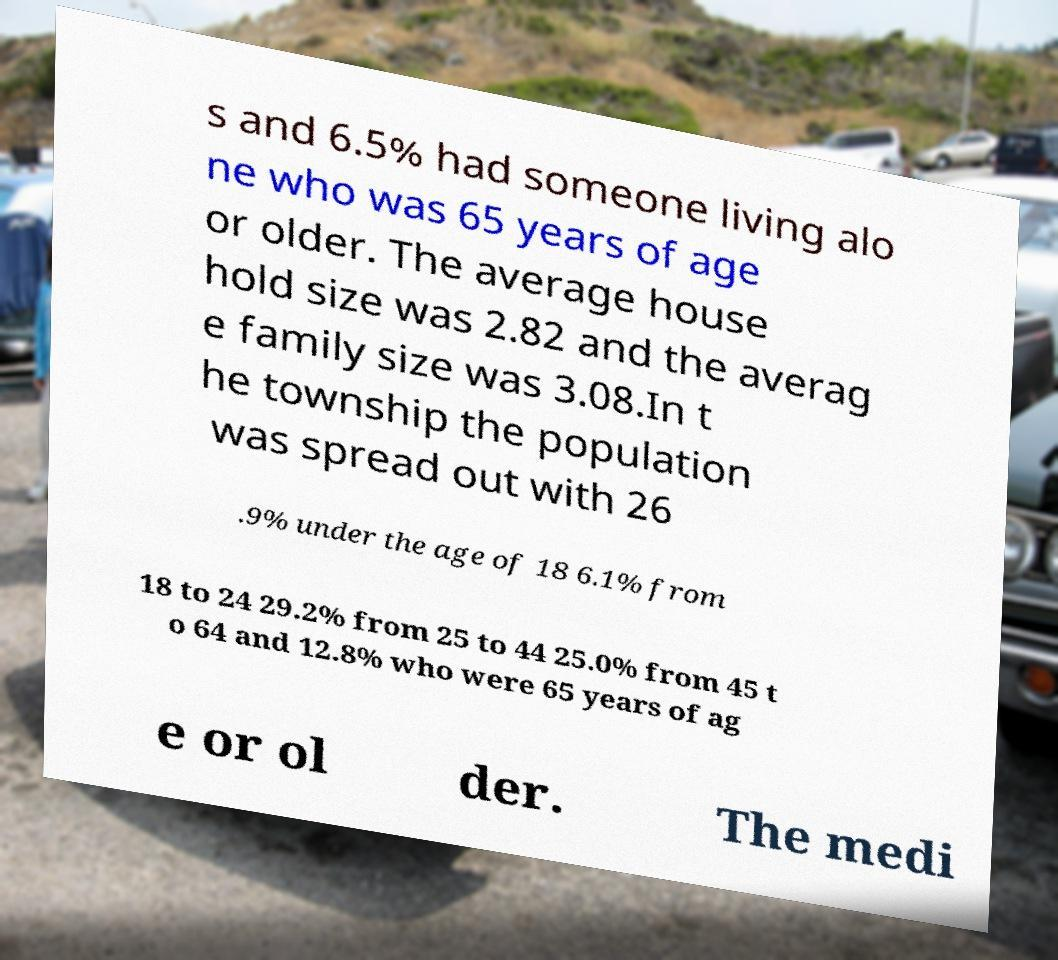Please identify and transcribe the text found in this image. s and 6.5% had someone living alo ne who was 65 years of age or older. The average house hold size was 2.82 and the averag e family size was 3.08.In t he township the population was spread out with 26 .9% under the age of 18 6.1% from 18 to 24 29.2% from 25 to 44 25.0% from 45 t o 64 and 12.8% who were 65 years of ag e or ol der. The medi 